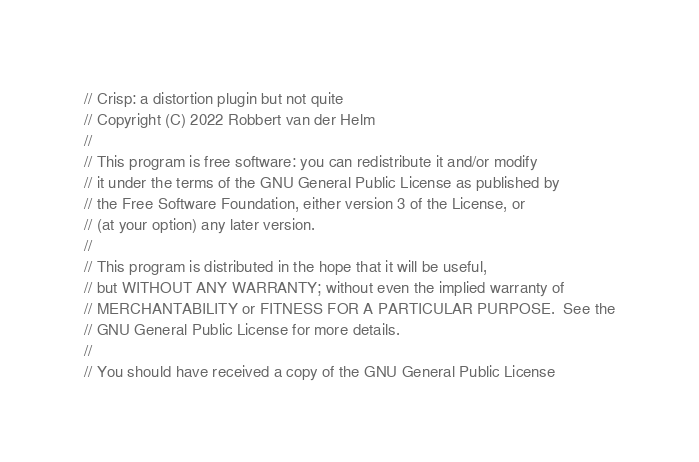<code> <loc_0><loc_0><loc_500><loc_500><_Rust_>// Crisp: a distortion plugin but not quite
// Copyright (C) 2022 Robbert van der Helm
//
// This program is free software: you can redistribute it and/or modify
// it under the terms of the GNU General Public License as published by
// the Free Software Foundation, either version 3 of the License, or
// (at your option) any later version.
//
// This program is distributed in the hope that it will be useful,
// but WITHOUT ANY WARRANTY; without even the implied warranty of
// MERCHANTABILITY or FITNESS FOR A PARTICULAR PURPOSE.  See the
// GNU General Public License for more details.
//
// You should have received a copy of the GNU General Public License</code> 